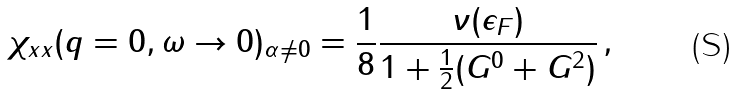<formula> <loc_0><loc_0><loc_500><loc_500>\chi _ { x x } ( q = 0 , \omega \rightarrow 0 ) _ { \alpha \neq 0 } = \frac { 1 } { 8 } \frac { \nu ( \epsilon _ { F } ) } { 1 + \frac { 1 } { 2 } ( G ^ { 0 } + G ^ { 2 } ) } \, ,</formula> 